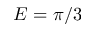Convert formula to latex. <formula><loc_0><loc_0><loc_500><loc_500>E = \pi / 3</formula> 